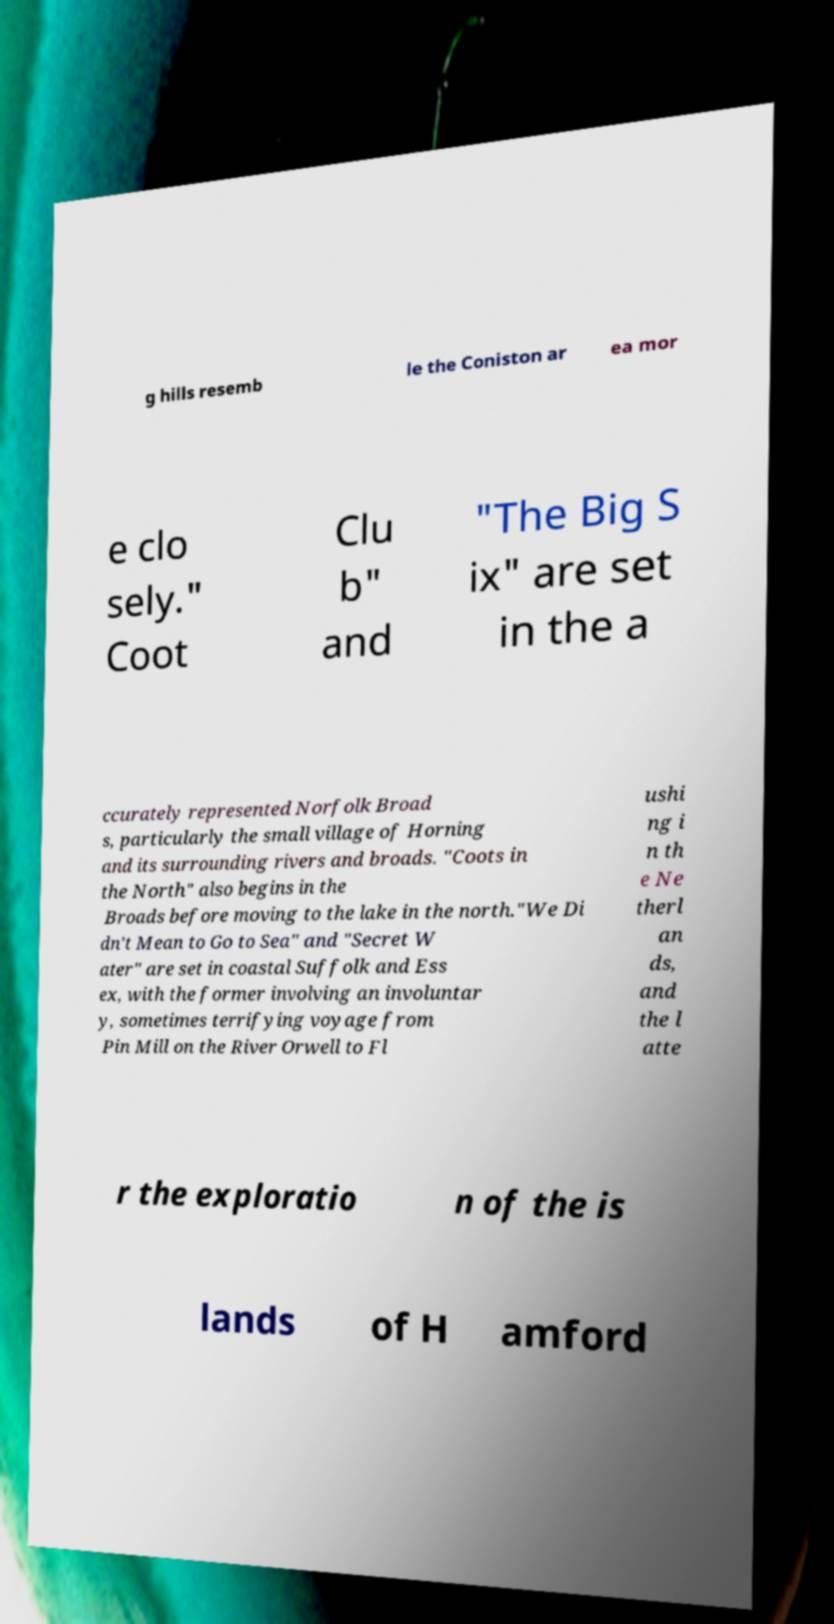For documentation purposes, I need the text within this image transcribed. Could you provide that? g hills resemb le the Coniston ar ea mor e clo sely." Coot Clu b" and "The Big S ix" are set in the a ccurately represented Norfolk Broad s, particularly the small village of Horning and its surrounding rivers and broads. "Coots in the North" also begins in the Broads before moving to the lake in the north."We Di dn't Mean to Go to Sea" and "Secret W ater" are set in coastal Suffolk and Ess ex, with the former involving an involuntar y, sometimes terrifying voyage from Pin Mill on the River Orwell to Fl ushi ng i n th e Ne therl an ds, and the l atte r the exploratio n of the is lands of H amford 